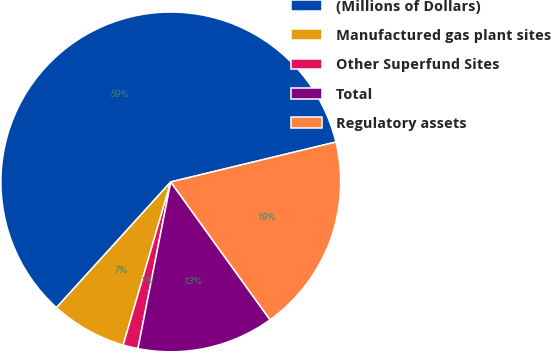<chart> <loc_0><loc_0><loc_500><loc_500><pie_chart><fcel>(Millions of Dollars)<fcel>Manufactured gas plant sites<fcel>Other Superfund Sites<fcel>Total<fcel>Regulatory assets<nl><fcel>59.48%<fcel>7.23%<fcel>1.42%<fcel>13.03%<fcel>18.84%<nl></chart> 